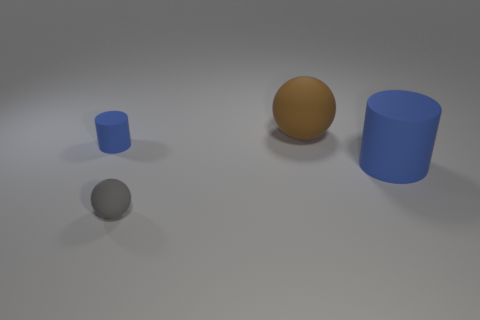Are there any small matte balls of the same color as the tiny matte cylinder?
Your answer should be compact. No. Are there the same number of big blue rubber cylinders right of the large blue object and tiny things left of the gray rubber thing?
Provide a succinct answer. No. Do the big blue matte thing and the small matte object that is in front of the tiny rubber cylinder have the same shape?
Offer a terse response. No. What number of other things are there of the same material as the brown ball
Make the answer very short. 3. There is a gray matte thing; are there any large cylinders in front of it?
Provide a succinct answer. No. There is a gray matte thing; is it the same size as the blue rubber thing that is to the right of the gray sphere?
Your response must be concise. No. There is a small matte thing that is behind the large blue cylinder behind the gray rubber ball; what is its color?
Give a very brief answer. Blue. Is the brown object the same size as the gray thing?
Offer a very short reply. No. What is the color of the matte object that is right of the tiny blue thing and behind the large blue rubber cylinder?
Give a very brief answer. Brown. How big is the brown matte thing?
Provide a short and direct response. Large. 